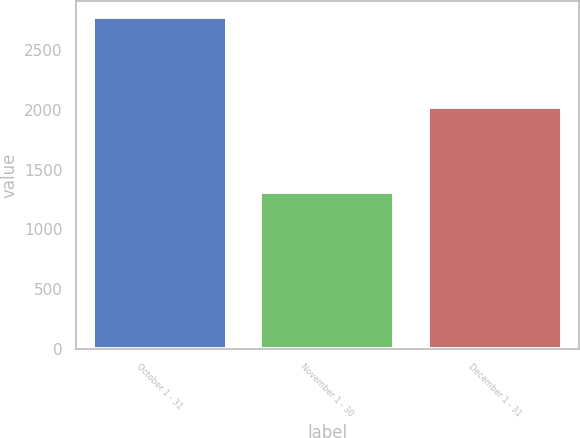Convert chart. <chart><loc_0><loc_0><loc_500><loc_500><bar_chart><fcel>October 1 - 31<fcel>November 1 - 30<fcel>December 1 - 31<nl><fcel>2772<fcel>1311<fcel>2026<nl></chart> 